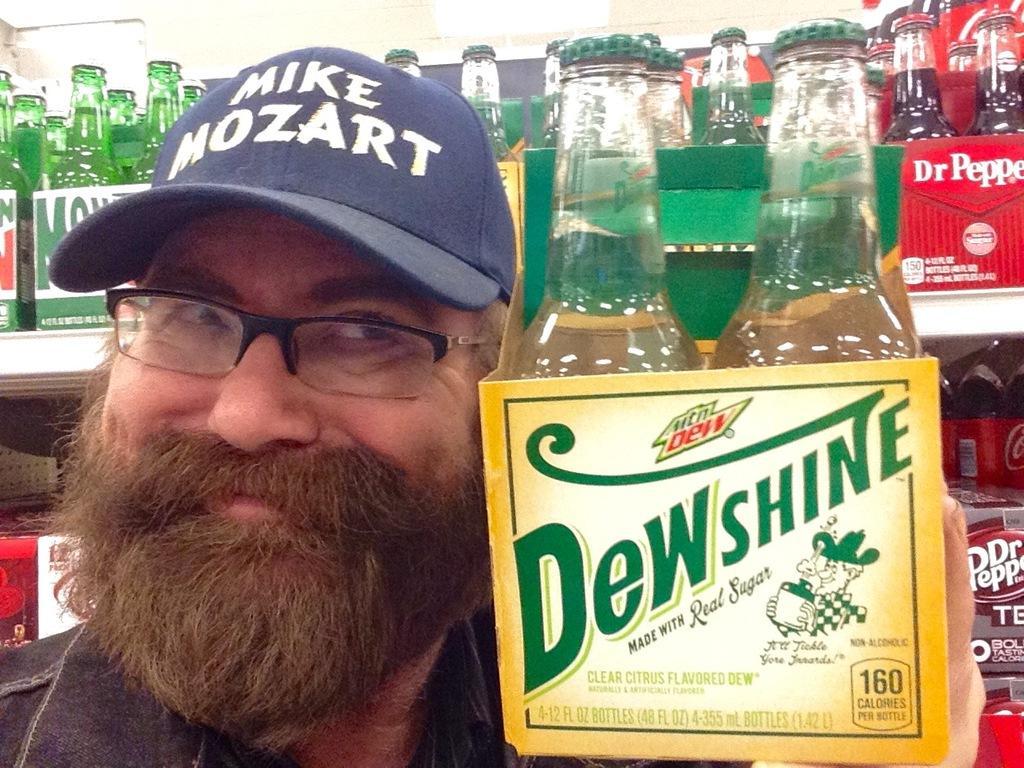Describe this image in one or two sentences. In this image i can see a man holding a bottle at the background i can see few bottles on a rack. 